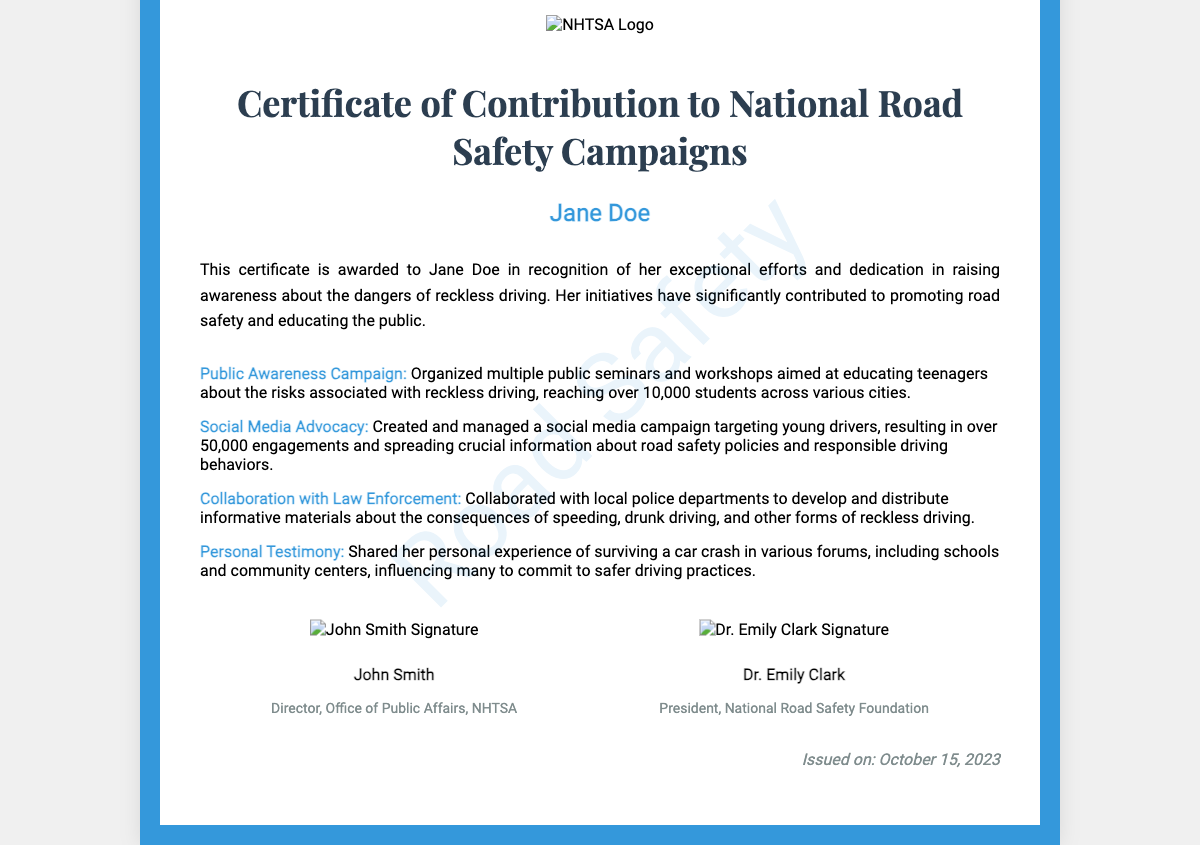What is the name of the recipient? The document's main content highlights the award recipient, which is listed in the recipient section.
Answer: Jane Doe What is the title of the certificate? The title is prominently displayed at the top of the document, indicating the type of recognition.
Answer: Certificate of Contribution to National Road Safety Campaigns What organization issued the certificate? The logo present on the certificate identifies the issuing authority, specifically the agency responsible for the award.
Answer: NHTSA How many students were reached through the public awareness campaign? The description of this contribution specifies the number of students targeted during the campaign.
Answer: Over 10,000 When was the certificate issued? The date of issuance is clearly stated at the bottom of the document, providing a specific reference point.
Answer: October 15, 2023 Who is the director of the Office of Public Affairs at NHTSA? The document lists signatures and titles, including that of the director, which serves as an official acknowledgment.
Answer: John Smith Which campaign had over 50,000 engagements? The contributions section outlines specific advocacy efforts, highlighting one that resulted in a substantial engagement number.
Answer: Social Media Advocacy What personal experience did Jane Doe share? The contributions detail her involvement in sharing significant personal experiences related to reckless driving.
Answer: Surviving a car crash What is the focus of Jane Doe's contributions? The documentary evidence emphasizes the overall goal of the named initiatives and efforts.
Answer: Raising awareness about reckless driving 